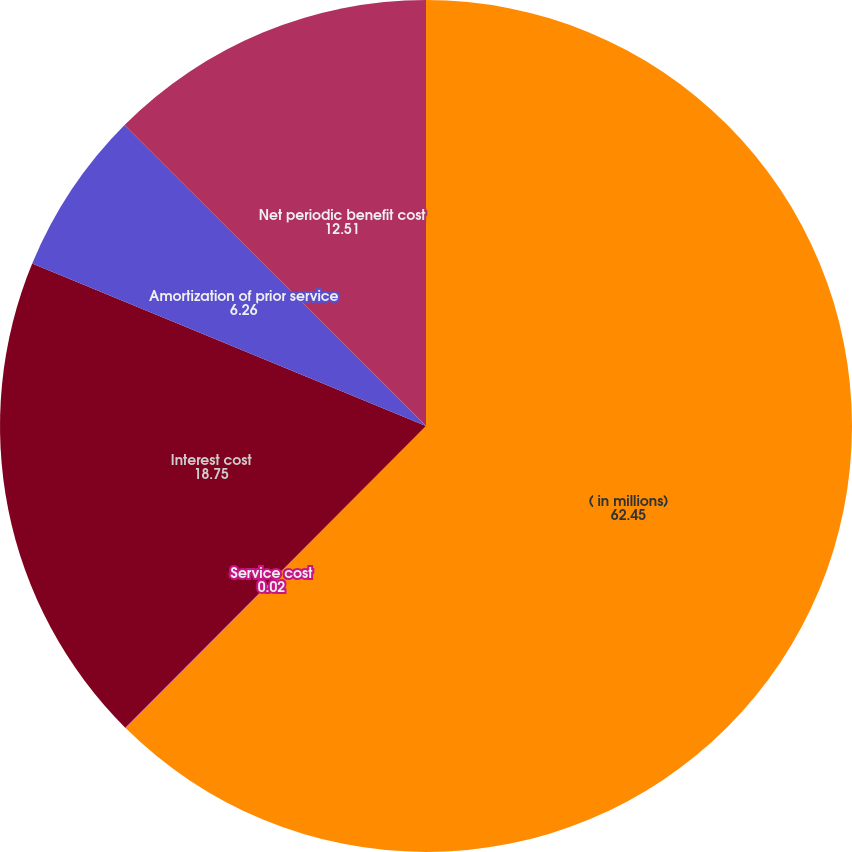Convert chart to OTSL. <chart><loc_0><loc_0><loc_500><loc_500><pie_chart><fcel>( in millions)<fcel>Service cost<fcel>Interest cost<fcel>Amortization of prior service<fcel>Net periodic benefit cost<nl><fcel>62.45%<fcel>0.02%<fcel>18.75%<fcel>6.26%<fcel>12.51%<nl></chart> 